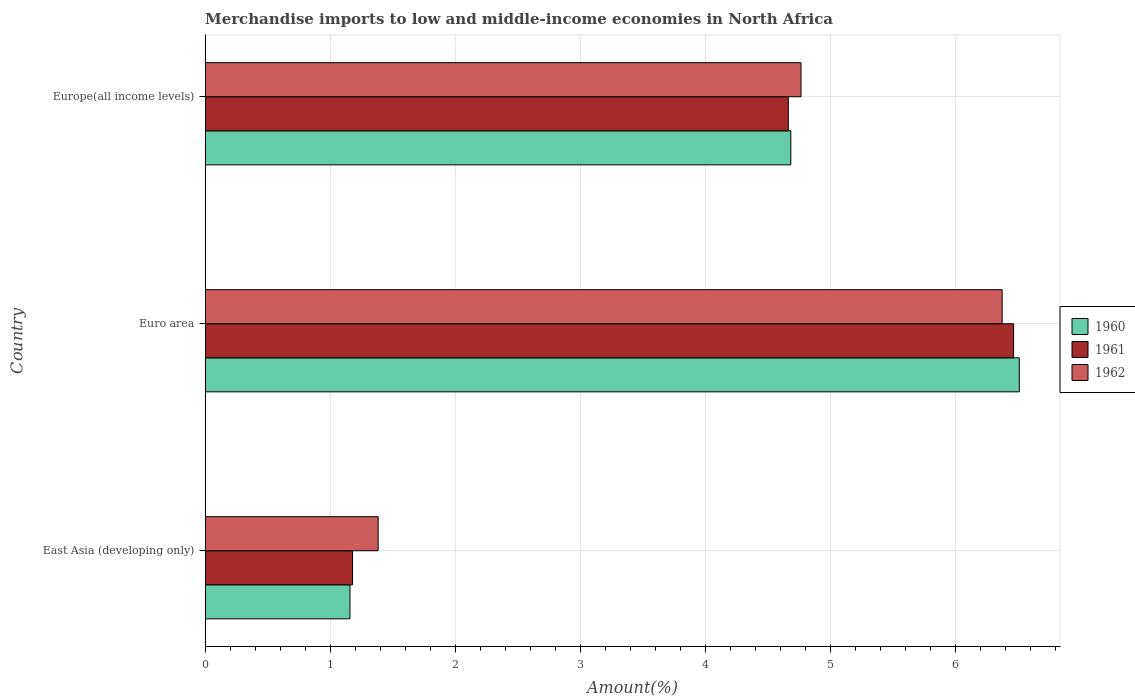Are the number of bars per tick equal to the number of legend labels?
Your response must be concise. Yes. Are the number of bars on each tick of the Y-axis equal?
Your answer should be very brief. Yes. How many bars are there on the 2nd tick from the top?
Provide a short and direct response. 3. What is the label of the 3rd group of bars from the top?
Offer a very short reply. East Asia (developing only). What is the percentage of amount earned from merchandise imports in 1962 in Euro area?
Provide a succinct answer. 6.37. Across all countries, what is the maximum percentage of amount earned from merchandise imports in 1962?
Offer a terse response. 6.37. Across all countries, what is the minimum percentage of amount earned from merchandise imports in 1960?
Offer a terse response. 1.16. In which country was the percentage of amount earned from merchandise imports in 1960 minimum?
Your response must be concise. East Asia (developing only). What is the total percentage of amount earned from merchandise imports in 1960 in the graph?
Offer a terse response. 12.35. What is the difference between the percentage of amount earned from merchandise imports in 1962 in East Asia (developing only) and that in Euro area?
Your response must be concise. -4.99. What is the difference between the percentage of amount earned from merchandise imports in 1960 in Euro area and the percentage of amount earned from merchandise imports in 1962 in Europe(all income levels)?
Keep it short and to the point. 1.74. What is the average percentage of amount earned from merchandise imports in 1960 per country?
Make the answer very short. 4.12. What is the difference between the percentage of amount earned from merchandise imports in 1962 and percentage of amount earned from merchandise imports in 1960 in Europe(all income levels)?
Your answer should be compact. 0.08. What is the ratio of the percentage of amount earned from merchandise imports in 1961 in Euro area to that in Europe(all income levels)?
Your answer should be compact. 1.39. Is the percentage of amount earned from merchandise imports in 1962 in East Asia (developing only) less than that in Europe(all income levels)?
Your answer should be compact. Yes. What is the difference between the highest and the second highest percentage of amount earned from merchandise imports in 1962?
Offer a very short reply. 1.61. What is the difference between the highest and the lowest percentage of amount earned from merchandise imports in 1962?
Your response must be concise. 4.99. What does the 3rd bar from the top in Euro area represents?
Give a very brief answer. 1960. What does the 2nd bar from the bottom in Euro area represents?
Provide a succinct answer. 1961. Is it the case that in every country, the sum of the percentage of amount earned from merchandise imports in 1962 and percentage of amount earned from merchandise imports in 1961 is greater than the percentage of amount earned from merchandise imports in 1960?
Your response must be concise. Yes. How many bars are there?
Ensure brevity in your answer.  9. How many countries are there in the graph?
Give a very brief answer. 3. Does the graph contain any zero values?
Offer a terse response. No. Does the graph contain grids?
Offer a terse response. Yes. What is the title of the graph?
Give a very brief answer. Merchandise imports to low and middle-income economies in North Africa. Does "1972" appear as one of the legend labels in the graph?
Provide a short and direct response. No. What is the label or title of the X-axis?
Your answer should be very brief. Amount(%). What is the Amount(%) in 1960 in East Asia (developing only)?
Offer a very short reply. 1.16. What is the Amount(%) of 1961 in East Asia (developing only)?
Offer a very short reply. 1.18. What is the Amount(%) in 1962 in East Asia (developing only)?
Make the answer very short. 1.38. What is the Amount(%) of 1960 in Euro area?
Give a very brief answer. 6.51. What is the Amount(%) in 1961 in Euro area?
Provide a short and direct response. 6.46. What is the Amount(%) in 1962 in Euro area?
Ensure brevity in your answer.  6.37. What is the Amount(%) in 1960 in Europe(all income levels)?
Offer a terse response. 4.68. What is the Amount(%) in 1961 in Europe(all income levels)?
Your answer should be compact. 4.66. What is the Amount(%) in 1962 in Europe(all income levels)?
Make the answer very short. 4.76. Across all countries, what is the maximum Amount(%) in 1960?
Offer a very short reply. 6.51. Across all countries, what is the maximum Amount(%) of 1961?
Offer a terse response. 6.46. Across all countries, what is the maximum Amount(%) of 1962?
Make the answer very short. 6.37. Across all countries, what is the minimum Amount(%) of 1960?
Provide a succinct answer. 1.16. Across all countries, what is the minimum Amount(%) of 1961?
Keep it short and to the point. 1.18. Across all countries, what is the minimum Amount(%) of 1962?
Offer a terse response. 1.38. What is the total Amount(%) of 1960 in the graph?
Offer a very short reply. 12.35. What is the total Amount(%) in 1961 in the graph?
Provide a short and direct response. 12.3. What is the total Amount(%) of 1962 in the graph?
Your answer should be compact. 12.52. What is the difference between the Amount(%) in 1960 in East Asia (developing only) and that in Euro area?
Make the answer very short. -5.35. What is the difference between the Amount(%) of 1961 in East Asia (developing only) and that in Euro area?
Ensure brevity in your answer.  -5.28. What is the difference between the Amount(%) in 1962 in East Asia (developing only) and that in Euro area?
Your response must be concise. -4.99. What is the difference between the Amount(%) in 1960 in East Asia (developing only) and that in Europe(all income levels)?
Give a very brief answer. -3.52. What is the difference between the Amount(%) of 1961 in East Asia (developing only) and that in Europe(all income levels)?
Your answer should be very brief. -3.48. What is the difference between the Amount(%) in 1962 in East Asia (developing only) and that in Europe(all income levels)?
Make the answer very short. -3.38. What is the difference between the Amount(%) of 1960 in Euro area and that in Europe(all income levels)?
Offer a terse response. 1.83. What is the difference between the Amount(%) of 1961 in Euro area and that in Europe(all income levels)?
Your answer should be compact. 1.8. What is the difference between the Amount(%) in 1962 in Euro area and that in Europe(all income levels)?
Your answer should be compact. 1.61. What is the difference between the Amount(%) in 1960 in East Asia (developing only) and the Amount(%) in 1961 in Euro area?
Your response must be concise. -5.31. What is the difference between the Amount(%) of 1960 in East Asia (developing only) and the Amount(%) of 1962 in Euro area?
Keep it short and to the point. -5.21. What is the difference between the Amount(%) of 1961 in East Asia (developing only) and the Amount(%) of 1962 in Euro area?
Ensure brevity in your answer.  -5.19. What is the difference between the Amount(%) in 1960 in East Asia (developing only) and the Amount(%) in 1961 in Europe(all income levels)?
Ensure brevity in your answer.  -3.5. What is the difference between the Amount(%) in 1960 in East Asia (developing only) and the Amount(%) in 1962 in Europe(all income levels)?
Ensure brevity in your answer.  -3.61. What is the difference between the Amount(%) in 1961 in East Asia (developing only) and the Amount(%) in 1962 in Europe(all income levels)?
Offer a terse response. -3.58. What is the difference between the Amount(%) in 1960 in Euro area and the Amount(%) in 1961 in Europe(all income levels)?
Make the answer very short. 1.85. What is the difference between the Amount(%) of 1960 in Euro area and the Amount(%) of 1962 in Europe(all income levels)?
Offer a terse response. 1.74. What is the difference between the Amount(%) of 1961 in Euro area and the Amount(%) of 1962 in Europe(all income levels)?
Provide a succinct answer. 1.7. What is the average Amount(%) in 1960 per country?
Give a very brief answer. 4.12. What is the average Amount(%) in 1961 per country?
Your answer should be compact. 4.1. What is the average Amount(%) in 1962 per country?
Give a very brief answer. 4.17. What is the difference between the Amount(%) in 1960 and Amount(%) in 1961 in East Asia (developing only)?
Give a very brief answer. -0.02. What is the difference between the Amount(%) of 1960 and Amount(%) of 1962 in East Asia (developing only)?
Make the answer very short. -0.23. What is the difference between the Amount(%) in 1961 and Amount(%) in 1962 in East Asia (developing only)?
Offer a very short reply. -0.2. What is the difference between the Amount(%) of 1960 and Amount(%) of 1961 in Euro area?
Your response must be concise. 0.05. What is the difference between the Amount(%) of 1960 and Amount(%) of 1962 in Euro area?
Offer a terse response. 0.14. What is the difference between the Amount(%) in 1961 and Amount(%) in 1962 in Euro area?
Keep it short and to the point. 0.09. What is the difference between the Amount(%) in 1960 and Amount(%) in 1961 in Europe(all income levels)?
Offer a terse response. 0.02. What is the difference between the Amount(%) in 1960 and Amount(%) in 1962 in Europe(all income levels)?
Your answer should be compact. -0.08. What is the difference between the Amount(%) in 1961 and Amount(%) in 1962 in Europe(all income levels)?
Ensure brevity in your answer.  -0.1. What is the ratio of the Amount(%) in 1960 in East Asia (developing only) to that in Euro area?
Your response must be concise. 0.18. What is the ratio of the Amount(%) of 1961 in East Asia (developing only) to that in Euro area?
Provide a short and direct response. 0.18. What is the ratio of the Amount(%) of 1962 in East Asia (developing only) to that in Euro area?
Offer a terse response. 0.22. What is the ratio of the Amount(%) in 1960 in East Asia (developing only) to that in Europe(all income levels)?
Provide a short and direct response. 0.25. What is the ratio of the Amount(%) of 1961 in East Asia (developing only) to that in Europe(all income levels)?
Give a very brief answer. 0.25. What is the ratio of the Amount(%) of 1962 in East Asia (developing only) to that in Europe(all income levels)?
Offer a terse response. 0.29. What is the ratio of the Amount(%) of 1960 in Euro area to that in Europe(all income levels)?
Your response must be concise. 1.39. What is the ratio of the Amount(%) of 1961 in Euro area to that in Europe(all income levels)?
Keep it short and to the point. 1.39. What is the ratio of the Amount(%) in 1962 in Euro area to that in Europe(all income levels)?
Keep it short and to the point. 1.34. What is the difference between the highest and the second highest Amount(%) of 1960?
Offer a terse response. 1.83. What is the difference between the highest and the second highest Amount(%) of 1961?
Offer a terse response. 1.8. What is the difference between the highest and the second highest Amount(%) of 1962?
Give a very brief answer. 1.61. What is the difference between the highest and the lowest Amount(%) of 1960?
Make the answer very short. 5.35. What is the difference between the highest and the lowest Amount(%) in 1961?
Your response must be concise. 5.28. What is the difference between the highest and the lowest Amount(%) in 1962?
Provide a succinct answer. 4.99. 